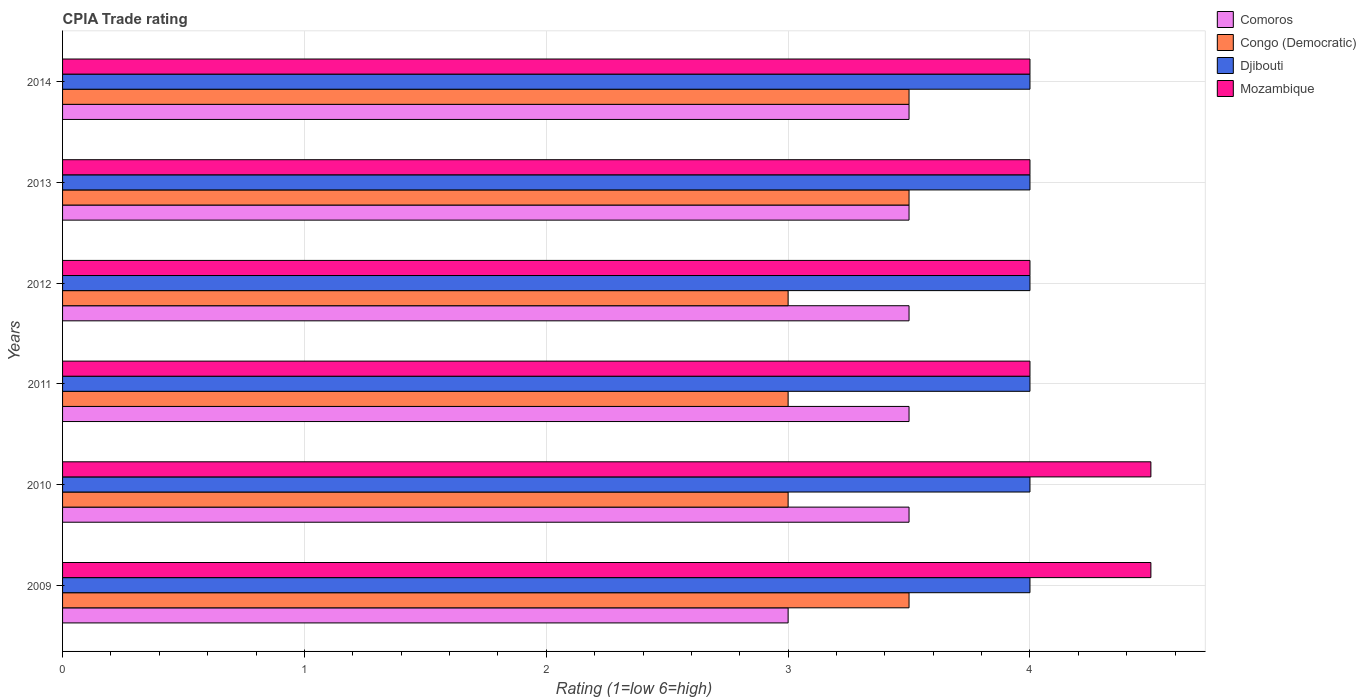How many different coloured bars are there?
Ensure brevity in your answer.  4. How many bars are there on the 1st tick from the top?
Ensure brevity in your answer.  4. How many bars are there on the 2nd tick from the bottom?
Your response must be concise. 4. What is the label of the 6th group of bars from the top?
Offer a very short reply. 2009. Across all years, what is the maximum CPIA rating in Comoros?
Provide a succinct answer. 3.5. Across all years, what is the minimum CPIA rating in Mozambique?
Your response must be concise. 4. In which year was the CPIA rating in Congo (Democratic) maximum?
Provide a succinct answer. 2009. What is the difference between the CPIA rating in Congo (Democratic) in 2009 and that in 2011?
Offer a very short reply. 0.5. What is the difference between the CPIA rating in Congo (Democratic) in 2009 and the CPIA rating in Mozambique in 2014?
Your answer should be compact. -0.5. In how many years, is the CPIA rating in Comoros greater than 4.4 ?
Your answer should be very brief. 0. What is the ratio of the CPIA rating in Mozambique in 2011 to that in 2014?
Make the answer very short. 1. What is the difference between the highest and the second highest CPIA rating in Congo (Democratic)?
Keep it short and to the point. 0. What is the difference between the highest and the lowest CPIA rating in Djibouti?
Offer a very short reply. 0. In how many years, is the CPIA rating in Mozambique greater than the average CPIA rating in Mozambique taken over all years?
Offer a terse response. 2. Is it the case that in every year, the sum of the CPIA rating in Comoros and CPIA rating in Mozambique is greater than the sum of CPIA rating in Djibouti and CPIA rating in Congo (Democratic)?
Your answer should be very brief. Yes. What does the 4th bar from the top in 2014 represents?
Offer a very short reply. Comoros. What does the 2nd bar from the bottom in 2014 represents?
Offer a very short reply. Congo (Democratic). How many bars are there?
Make the answer very short. 24. How many years are there in the graph?
Your answer should be very brief. 6. What is the difference between two consecutive major ticks on the X-axis?
Provide a succinct answer. 1. Are the values on the major ticks of X-axis written in scientific E-notation?
Give a very brief answer. No. Does the graph contain grids?
Offer a very short reply. Yes. How many legend labels are there?
Ensure brevity in your answer.  4. What is the title of the graph?
Make the answer very short. CPIA Trade rating. What is the label or title of the X-axis?
Ensure brevity in your answer.  Rating (1=low 6=high). What is the label or title of the Y-axis?
Offer a terse response. Years. What is the Rating (1=low 6=high) in Comoros in 2009?
Give a very brief answer. 3. What is the Rating (1=low 6=high) of Comoros in 2010?
Keep it short and to the point. 3.5. What is the Rating (1=low 6=high) of Mozambique in 2010?
Provide a short and direct response. 4.5. What is the Rating (1=low 6=high) in Comoros in 2011?
Ensure brevity in your answer.  3.5. What is the Rating (1=low 6=high) in Congo (Democratic) in 2011?
Your answer should be very brief. 3. What is the Rating (1=low 6=high) in Mozambique in 2011?
Make the answer very short. 4. What is the Rating (1=low 6=high) in Comoros in 2012?
Make the answer very short. 3.5. What is the Rating (1=low 6=high) in Congo (Democratic) in 2012?
Your response must be concise. 3. What is the Rating (1=low 6=high) in Mozambique in 2012?
Provide a short and direct response. 4. What is the Rating (1=low 6=high) in Congo (Democratic) in 2013?
Your answer should be compact. 3.5. What is the Rating (1=low 6=high) in Comoros in 2014?
Keep it short and to the point. 3.5. What is the Rating (1=low 6=high) of Mozambique in 2014?
Provide a short and direct response. 4. Across all years, what is the maximum Rating (1=low 6=high) in Congo (Democratic)?
Your response must be concise. 3.5. Across all years, what is the minimum Rating (1=low 6=high) of Congo (Democratic)?
Offer a terse response. 3. Across all years, what is the minimum Rating (1=low 6=high) of Mozambique?
Your answer should be compact. 4. What is the total Rating (1=low 6=high) of Congo (Democratic) in the graph?
Your answer should be very brief. 19.5. What is the total Rating (1=low 6=high) of Djibouti in the graph?
Make the answer very short. 24. What is the total Rating (1=low 6=high) of Mozambique in the graph?
Your answer should be very brief. 25. What is the difference between the Rating (1=low 6=high) in Congo (Democratic) in 2009 and that in 2010?
Offer a very short reply. 0.5. What is the difference between the Rating (1=low 6=high) in Djibouti in 2009 and that in 2010?
Provide a short and direct response. 0. What is the difference between the Rating (1=low 6=high) of Djibouti in 2009 and that in 2011?
Provide a succinct answer. 0. What is the difference between the Rating (1=low 6=high) of Mozambique in 2009 and that in 2011?
Provide a short and direct response. 0.5. What is the difference between the Rating (1=low 6=high) of Comoros in 2009 and that in 2012?
Make the answer very short. -0.5. What is the difference between the Rating (1=low 6=high) in Congo (Democratic) in 2009 and that in 2012?
Your answer should be very brief. 0.5. What is the difference between the Rating (1=low 6=high) in Mozambique in 2009 and that in 2012?
Provide a succinct answer. 0.5. What is the difference between the Rating (1=low 6=high) of Comoros in 2009 and that in 2013?
Ensure brevity in your answer.  -0.5. What is the difference between the Rating (1=low 6=high) in Congo (Democratic) in 2009 and that in 2013?
Your answer should be compact. 0. What is the difference between the Rating (1=low 6=high) in Djibouti in 2009 and that in 2013?
Ensure brevity in your answer.  0. What is the difference between the Rating (1=low 6=high) in Mozambique in 2009 and that in 2013?
Keep it short and to the point. 0.5. What is the difference between the Rating (1=low 6=high) in Djibouti in 2009 and that in 2014?
Make the answer very short. 0. What is the difference between the Rating (1=low 6=high) of Comoros in 2010 and that in 2011?
Your answer should be very brief. 0. What is the difference between the Rating (1=low 6=high) of Congo (Democratic) in 2010 and that in 2011?
Your answer should be very brief. 0. What is the difference between the Rating (1=low 6=high) in Djibouti in 2010 and that in 2011?
Make the answer very short. 0. What is the difference between the Rating (1=low 6=high) of Comoros in 2010 and that in 2012?
Make the answer very short. 0. What is the difference between the Rating (1=low 6=high) in Mozambique in 2010 and that in 2012?
Your answer should be very brief. 0.5. What is the difference between the Rating (1=low 6=high) of Comoros in 2010 and that in 2013?
Your answer should be very brief. 0. What is the difference between the Rating (1=low 6=high) in Congo (Democratic) in 2010 and that in 2013?
Your response must be concise. -0.5. What is the difference between the Rating (1=low 6=high) in Djibouti in 2010 and that in 2013?
Give a very brief answer. 0. What is the difference between the Rating (1=low 6=high) of Mozambique in 2010 and that in 2013?
Offer a terse response. 0.5. What is the difference between the Rating (1=low 6=high) of Comoros in 2011 and that in 2012?
Give a very brief answer. 0. What is the difference between the Rating (1=low 6=high) in Djibouti in 2011 and that in 2012?
Your answer should be very brief. 0. What is the difference between the Rating (1=low 6=high) in Mozambique in 2011 and that in 2012?
Provide a short and direct response. 0. What is the difference between the Rating (1=low 6=high) in Congo (Democratic) in 2011 and that in 2013?
Keep it short and to the point. -0.5. What is the difference between the Rating (1=low 6=high) in Comoros in 2012 and that in 2013?
Ensure brevity in your answer.  0. What is the difference between the Rating (1=low 6=high) of Congo (Democratic) in 2012 and that in 2013?
Offer a very short reply. -0.5. What is the difference between the Rating (1=low 6=high) of Mozambique in 2012 and that in 2013?
Your answer should be compact. 0. What is the difference between the Rating (1=low 6=high) of Comoros in 2012 and that in 2014?
Make the answer very short. 0. What is the difference between the Rating (1=low 6=high) of Congo (Democratic) in 2013 and that in 2014?
Your answer should be compact. 0. What is the difference between the Rating (1=low 6=high) in Djibouti in 2013 and that in 2014?
Your response must be concise. 0. What is the difference between the Rating (1=low 6=high) in Mozambique in 2013 and that in 2014?
Your answer should be compact. 0. What is the difference between the Rating (1=low 6=high) of Comoros in 2009 and the Rating (1=low 6=high) of Djibouti in 2010?
Provide a succinct answer. -1. What is the difference between the Rating (1=low 6=high) of Djibouti in 2009 and the Rating (1=low 6=high) of Mozambique in 2010?
Make the answer very short. -0.5. What is the difference between the Rating (1=low 6=high) of Congo (Democratic) in 2009 and the Rating (1=low 6=high) of Djibouti in 2011?
Provide a succinct answer. -0.5. What is the difference between the Rating (1=low 6=high) of Djibouti in 2009 and the Rating (1=low 6=high) of Mozambique in 2011?
Provide a short and direct response. 0. What is the difference between the Rating (1=low 6=high) in Congo (Democratic) in 2009 and the Rating (1=low 6=high) in Djibouti in 2012?
Offer a terse response. -0.5. What is the difference between the Rating (1=low 6=high) of Djibouti in 2009 and the Rating (1=low 6=high) of Mozambique in 2012?
Make the answer very short. 0. What is the difference between the Rating (1=low 6=high) in Comoros in 2009 and the Rating (1=low 6=high) in Congo (Democratic) in 2013?
Keep it short and to the point. -0.5. What is the difference between the Rating (1=low 6=high) in Congo (Democratic) in 2009 and the Rating (1=low 6=high) in Djibouti in 2013?
Offer a terse response. -0.5. What is the difference between the Rating (1=low 6=high) of Congo (Democratic) in 2009 and the Rating (1=low 6=high) of Mozambique in 2013?
Your answer should be very brief. -0.5. What is the difference between the Rating (1=low 6=high) of Djibouti in 2009 and the Rating (1=low 6=high) of Mozambique in 2013?
Provide a short and direct response. 0. What is the difference between the Rating (1=low 6=high) in Congo (Democratic) in 2009 and the Rating (1=low 6=high) in Djibouti in 2014?
Your answer should be very brief. -0.5. What is the difference between the Rating (1=low 6=high) in Djibouti in 2009 and the Rating (1=low 6=high) in Mozambique in 2014?
Provide a short and direct response. 0. What is the difference between the Rating (1=low 6=high) in Comoros in 2010 and the Rating (1=low 6=high) in Congo (Democratic) in 2011?
Offer a terse response. 0.5. What is the difference between the Rating (1=low 6=high) of Comoros in 2010 and the Rating (1=low 6=high) of Djibouti in 2011?
Provide a short and direct response. -0.5. What is the difference between the Rating (1=low 6=high) in Comoros in 2010 and the Rating (1=low 6=high) in Mozambique in 2011?
Offer a terse response. -0.5. What is the difference between the Rating (1=low 6=high) of Congo (Democratic) in 2010 and the Rating (1=low 6=high) of Mozambique in 2011?
Ensure brevity in your answer.  -1. What is the difference between the Rating (1=low 6=high) of Comoros in 2010 and the Rating (1=low 6=high) of Congo (Democratic) in 2012?
Make the answer very short. 0.5. What is the difference between the Rating (1=low 6=high) of Congo (Democratic) in 2010 and the Rating (1=low 6=high) of Djibouti in 2012?
Your answer should be very brief. -1. What is the difference between the Rating (1=low 6=high) of Congo (Democratic) in 2010 and the Rating (1=low 6=high) of Mozambique in 2012?
Keep it short and to the point. -1. What is the difference between the Rating (1=low 6=high) of Djibouti in 2010 and the Rating (1=low 6=high) of Mozambique in 2012?
Make the answer very short. 0. What is the difference between the Rating (1=low 6=high) in Comoros in 2010 and the Rating (1=low 6=high) in Congo (Democratic) in 2013?
Make the answer very short. 0. What is the difference between the Rating (1=low 6=high) in Comoros in 2010 and the Rating (1=low 6=high) in Djibouti in 2013?
Your answer should be very brief. -0.5. What is the difference between the Rating (1=low 6=high) of Congo (Democratic) in 2010 and the Rating (1=low 6=high) of Djibouti in 2013?
Offer a terse response. -1. What is the difference between the Rating (1=low 6=high) in Congo (Democratic) in 2010 and the Rating (1=low 6=high) in Mozambique in 2013?
Ensure brevity in your answer.  -1. What is the difference between the Rating (1=low 6=high) in Djibouti in 2010 and the Rating (1=low 6=high) in Mozambique in 2013?
Ensure brevity in your answer.  0. What is the difference between the Rating (1=low 6=high) in Comoros in 2010 and the Rating (1=low 6=high) in Congo (Democratic) in 2014?
Your response must be concise. 0. What is the difference between the Rating (1=low 6=high) of Congo (Democratic) in 2010 and the Rating (1=low 6=high) of Mozambique in 2014?
Ensure brevity in your answer.  -1. What is the difference between the Rating (1=low 6=high) in Comoros in 2011 and the Rating (1=low 6=high) in Djibouti in 2012?
Your answer should be very brief. -0.5. What is the difference between the Rating (1=low 6=high) in Comoros in 2011 and the Rating (1=low 6=high) in Mozambique in 2012?
Your answer should be compact. -0.5. What is the difference between the Rating (1=low 6=high) of Congo (Democratic) in 2011 and the Rating (1=low 6=high) of Mozambique in 2012?
Offer a terse response. -1. What is the difference between the Rating (1=low 6=high) of Djibouti in 2011 and the Rating (1=low 6=high) of Mozambique in 2012?
Ensure brevity in your answer.  0. What is the difference between the Rating (1=low 6=high) of Comoros in 2011 and the Rating (1=low 6=high) of Congo (Democratic) in 2013?
Your answer should be very brief. 0. What is the difference between the Rating (1=low 6=high) in Comoros in 2011 and the Rating (1=low 6=high) in Djibouti in 2013?
Your answer should be very brief. -0.5. What is the difference between the Rating (1=low 6=high) of Comoros in 2011 and the Rating (1=low 6=high) of Mozambique in 2013?
Keep it short and to the point. -0.5. What is the difference between the Rating (1=low 6=high) in Comoros in 2011 and the Rating (1=low 6=high) in Congo (Democratic) in 2014?
Provide a succinct answer. 0. What is the difference between the Rating (1=low 6=high) of Comoros in 2011 and the Rating (1=low 6=high) of Djibouti in 2014?
Your answer should be very brief. -0.5. What is the difference between the Rating (1=low 6=high) of Comoros in 2011 and the Rating (1=low 6=high) of Mozambique in 2014?
Ensure brevity in your answer.  -0.5. What is the difference between the Rating (1=low 6=high) in Congo (Democratic) in 2011 and the Rating (1=low 6=high) in Djibouti in 2014?
Ensure brevity in your answer.  -1. What is the difference between the Rating (1=low 6=high) in Comoros in 2012 and the Rating (1=low 6=high) in Djibouti in 2013?
Ensure brevity in your answer.  -0.5. What is the difference between the Rating (1=low 6=high) in Comoros in 2012 and the Rating (1=low 6=high) in Mozambique in 2013?
Keep it short and to the point. -0.5. What is the difference between the Rating (1=low 6=high) of Congo (Democratic) in 2012 and the Rating (1=low 6=high) of Djibouti in 2013?
Your answer should be very brief. -1. What is the difference between the Rating (1=low 6=high) in Congo (Democratic) in 2012 and the Rating (1=low 6=high) in Mozambique in 2013?
Keep it short and to the point. -1. What is the difference between the Rating (1=low 6=high) of Djibouti in 2012 and the Rating (1=low 6=high) of Mozambique in 2013?
Make the answer very short. 0. What is the difference between the Rating (1=low 6=high) in Comoros in 2012 and the Rating (1=low 6=high) in Djibouti in 2014?
Keep it short and to the point. -0.5. What is the difference between the Rating (1=low 6=high) in Comoros in 2012 and the Rating (1=low 6=high) in Mozambique in 2014?
Provide a succinct answer. -0.5. What is the difference between the Rating (1=low 6=high) in Comoros in 2013 and the Rating (1=low 6=high) in Congo (Democratic) in 2014?
Give a very brief answer. 0. What is the difference between the Rating (1=low 6=high) in Comoros in 2013 and the Rating (1=low 6=high) in Mozambique in 2014?
Provide a short and direct response. -0.5. What is the difference between the Rating (1=low 6=high) in Congo (Democratic) in 2013 and the Rating (1=low 6=high) in Djibouti in 2014?
Provide a succinct answer. -0.5. What is the difference between the Rating (1=low 6=high) of Congo (Democratic) in 2013 and the Rating (1=low 6=high) of Mozambique in 2014?
Ensure brevity in your answer.  -0.5. What is the average Rating (1=low 6=high) in Comoros per year?
Provide a short and direct response. 3.42. What is the average Rating (1=low 6=high) of Congo (Democratic) per year?
Offer a very short reply. 3.25. What is the average Rating (1=low 6=high) in Djibouti per year?
Provide a succinct answer. 4. What is the average Rating (1=low 6=high) of Mozambique per year?
Provide a short and direct response. 4.17. In the year 2009, what is the difference between the Rating (1=low 6=high) of Comoros and Rating (1=low 6=high) of Djibouti?
Your answer should be very brief. -1. In the year 2009, what is the difference between the Rating (1=low 6=high) of Comoros and Rating (1=low 6=high) of Mozambique?
Provide a short and direct response. -1.5. In the year 2009, what is the difference between the Rating (1=low 6=high) of Djibouti and Rating (1=low 6=high) of Mozambique?
Ensure brevity in your answer.  -0.5. In the year 2010, what is the difference between the Rating (1=low 6=high) of Comoros and Rating (1=low 6=high) of Congo (Democratic)?
Provide a short and direct response. 0.5. In the year 2010, what is the difference between the Rating (1=low 6=high) in Comoros and Rating (1=low 6=high) in Djibouti?
Offer a terse response. -0.5. In the year 2010, what is the difference between the Rating (1=low 6=high) of Congo (Democratic) and Rating (1=low 6=high) of Mozambique?
Your answer should be very brief. -1.5. In the year 2011, what is the difference between the Rating (1=low 6=high) in Comoros and Rating (1=low 6=high) in Djibouti?
Provide a short and direct response. -0.5. In the year 2011, what is the difference between the Rating (1=low 6=high) of Congo (Democratic) and Rating (1=low 6=high) of Djibouti?
Provide a succinct answer. -1. In the year 2011, what is the difference between the Rating (1=low 6=high) in Congo (Democratic) and Rating (1=low 6=high) in Mozambique?
Your answer should be compact. -1. In the year 2011, what is the difference between the Rating (1=low 6=high) in Djibouti and Rating (1=low 6=high) in Mozambique?
Provide a short and direct response. 0. In the year 2013, what is the difference between the Rating (1=low 6=high) of Comoros and Rating (1=low 6=high) of Djibouti?
Provide a succinct answer. -0.5. In the year 2013, what is the difference between the Rating (1=low 6=high) of Comoros and Rating (1=low 6=high) of Mozambique?
Provide a short and direct response. -0.5. In the year 2013, what is the difference between the Rating (1=low 6=high) of Congo (Democratic) and Rating (1=low 6=high) of Mozambique?
Your answer should be very brief. -0.5. In the year 2014, what is the difference between the Rating (1=low 6=high) of Comoros and Rating (1=low 6=high) of Congo (Democratic)?
Offer a very short reply. 0. In the year 2014, what is the difference between the Rating (1=low 6=high) of Comoros and Rating (1=low 6=high) of Mozambique?
Ensure brevity in your answer.  -0.5. In the year 2014, what is the difference between the Rating (1=low 6=high) in Congo (Democratic) and Rating (1=low 6=high) in Djibouti?
Ensure brevity in your answer.  -0.5. In the year 2014, what is the difference between the Rating (1=low 6=high) in Congo (Democratic) and Rating (1=low 6=high) in Mozambique?
Your response must be concise. -0.5. In the year 2014, what is the difference between the Rating (1=low 6=high) of Djibouti and Rating (1=low 6=high) of Mozambique?
Provide a short and direct response. 0. What is the ratio of the Rating (1=low 6=high) in Congo (Democratic) in 2009 to that in 2010?
Give a very brief answer. 1.17. What is the ratio of the Rating (1=low 6=high) in Djibouti in 2009 to that in 2010?
Offer a terse response. 1. What is the ratio of the Rating (1=low 6=high) of Comoros in 2009 to that in 2011?
Provide a succinct answer. 0.86. What is the ratio of the Rating (1=low 6=high) in Djibouti in 2009 to that in 2011?
Your answer should be compact. 1. What is the ratio of the Rating (1=low 6=high) in Mozambique in 2009 to that in 2011?
Your response must be concise. 1.12. What is the ratio of the Rating (1=low 6=high) of Comoros in 2009 to that in 2012?
Give a very brief answer. 0.86. What is the ratio of the Rating (1=low 6=high) in Congo (Democratic) in 2009 to that in 2012?
Your answer should be very brief. 1.17. What is the ratio of the Rating (1=low 6=high) of Djibouti in 2009 to that in 2012?
Your answer should be compact. 1. What is the ratio of the Rating (1=low 6=high) of Congo (Democratic) in 2009 to that in 2013?
Offer a very short reply. 1. What is the ratio of the Rating (1=low 6=high) in Mozambique in 2009 to that in 2013?
Ensure brevity in your answer.  1.12. What is the ratio of the Rating (1=low 6=high) in Comoros in 2009 to that in 2014?
Make the answer very short. 0.86. What is the ratio of the Rating (1=low 6=high) of Comoros in 2010 to that in 2011?
Keep it short and to the point. 1. What is the ratio of the Rating (1=low 6=high) of Djibouti in 2010 to that in 2011?
Give a very brief answer. 1. What is the ratio of the Rating (1=low 6=high) in Congo (Democratic) in 2010 to that in 2012?
Your answer should be very brief. 1. What is the ratio of the Rating (1=low 6=high) in Mozambique in 2010 to that in 2013?
Keep it short and to the point. 1.12. What is the ratio of the Rating (1=low 6=high) in Comoros in 2011 to that in 2012?
Your answer should be very brief. 1. What is the ratio of the Rating (1=low 6=high) of Congo (Democratic) in 2011 to that in 2012?
Offer a terse response. 1. What is the ratio of the Rating (1=low 6=high) in Djibouti in 2011 to that in 2012?
Your answer should be compact. 1. What is the ratio of the Rating (1=low 6=high) in Comoros in 2011 to that in 2013?
Give a very brief answer. 1. What is the ratio of the Rating (1=low 6=high) of Djibouti in 2011 to that in 2013?
Your answer should be compact. 1. What is the ratio of the Rating (1=low 6=high) in Mozambique in 2011 to that in 2013?
Offer a very short reply. 1. What is the ratio of the Rating (1=low 6=high) of Congo (Democratic) in 2011 to that in 2014?
Make the answer very short. 0.86. What is the ratio of the Rating (1=low 6=high) in Djibouti in 2011 to that in 2014?
Your response must be concise. 1. What is the ratio of the Rating (1=low 6=high) in Mozambique in 2011 to that in 2014?
Offer a very short reply. 1. What is the ratio of the Rating (1=low 6=high) in Comoros in 2012 to that in 2013?
Ensure brevity in your answer.  1. What is the ratio of the Rating (1=low 6=high) of Djibouti in 2012 to that in 2013?
Provide a succinct answer. 1. What is the ratio of the Rating (1=low 6=high) in Comoros in 2012 to that in 2014?
Offer a terse response. 1. What is the ratio of the Rating (1=low 6=high) of Congo (Democratic) in 2013 to that in 2014?
Ensure brevity in your answer.  1. What is the ratio of the Rating (1=low 6=high) of Mozambique in 2013 to that in 2014?
Your response must be concise. 1. What is the difference between the highest and the second highest Rating (1=low 6=high) in Comoros?
Ensure brevity in your answer.  0. What is the difference between the highest and the second highest Rating (1=low 6=high) in Congo (Democratic)?
Give a very brief answer. 0. What is the difference between the highest and the second highest Rating (1=low 6=high) of Mozambique?
Make the answer very short. 0. What is the difference between the highest and the lowest Rating (1=low 6=high) in Comoros?
Provide a succinct answer. 0.5. 